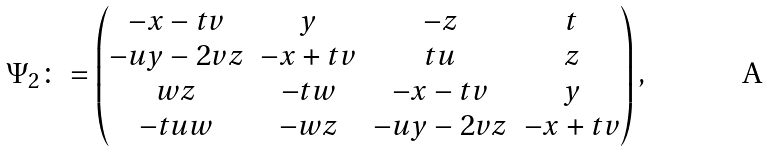Convert formula to latex. <formula><loc_0><loc_0><loc_500><loc_500>\Psi _ { 2 } \colon = \begin{pmatrix} - x - t v & y & - z & t \\ - u y - 2 v z & - x + t v & t u & z \\ w z & - t w & - x - t v & y \\ - t u w & - w z & - u y - 2 v z & - x + t v \end{pmatrix} ,</formula> 